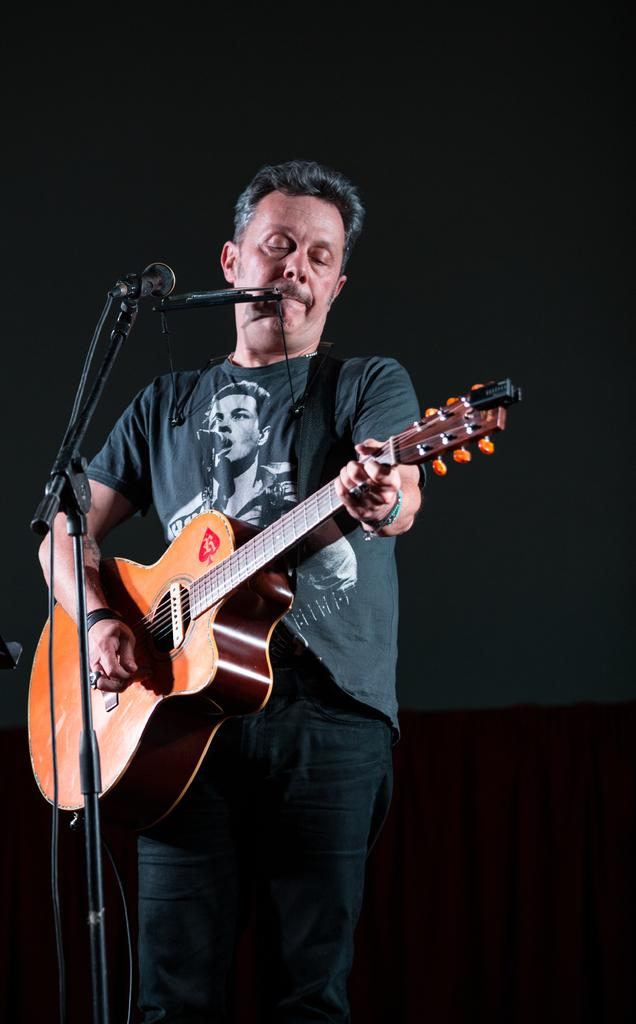Who is the main subject in the image? There is a man in the image. What is the man doing in the image? The man is standing and playing a guitar. What object is in front of the man? There is a microphone in front of the man. How many cows are visible in the image? There are no cows present in the image. What decision is the man making while playing the guitar in the image? The image does not provide information about any decisions the man is making while playing the guitar. 